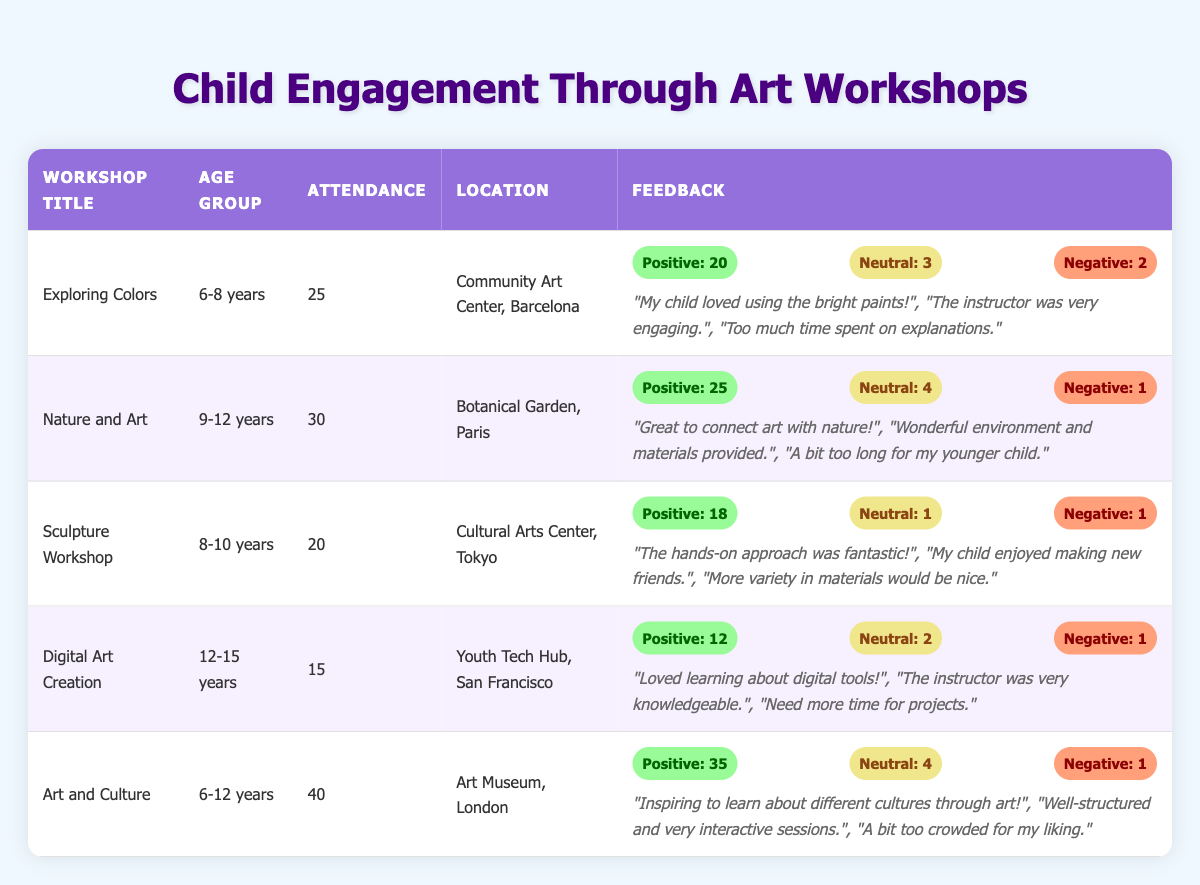What is the title of the workshop with the highest attendance? By inspecting the attendance numbers in the table, the workshop titled "Art and Culture" has the highest attendance at 40 participants.
Answer: Art and Culture How many positive feedback comments were received for the "Nature and Art" workshop? The table shows that the "Nature and Art" workshop received 25 positive feedback comments.
Answer: 25 Which workshop had the least attendance? "Digital Art Creation" had the least attendance with only 15 participants, as indicated in the attendance column.
Answer: 15 What is the total number of negative feedback comments across all workshops? The negative comments in the table add up: 2 (Exploring Colors) + 1 (Nature and Art) + 1 (Sculpture Workshop) + 1 (Digital Art Creation) + 1 (Art and Culture) = 6.
Answer: 6 Is there any workshop where all feedback was positive or neutral? The "Sculpture Workshop" and "Digital Art Creation" had only one negative comment each, indicating that most feedback was positive or neutral. However, none had all feedback positive.
Answer: No How does the attendance of the "Digital Art Creation" workshop compare to the average attendance of all workshops? The average attendance is calculated by adding up all participants (25 + 30 + 20 + 15 + 40 = 130) and dividing by 5 (130/5 = 26). "Digital Art Creation" had 15 attendees, which is below the average.
Answer: Below average Which workshop received the highest number of negative comments and how many were there? The "Exploring Colors" workshop received the highest number of negative comments, totaling 2. This is clearly stated in the feedback section.
Answer: 2 For which age group was the "Sculpture Workshop" designed, and how does its attendance compare to the "Art and Culture" workshop? "Sculpture Workshop" is designed for the 8-10 years age group with 20 attendees. "Art and Culture," designed for ages 6-12, had 40 attendees, which is 20 more than the sculpture workshop.
Answer: 8-10 years, 20 fewer attendees How many workshops were held in Barcelona? There is 1 workshop held in Barcelona, which is "Exploring Colors," as shown by its location in the table.
Answer: 1 Calculate the percentage of positive feedback for the "Art and Culture" workshop. The percentage is calculated by taking the positive feedback (35) divided by total participants (40) multiplied by 100. Thus, (35/40) * 100 = 87.5%.
Answer: 87.5% 